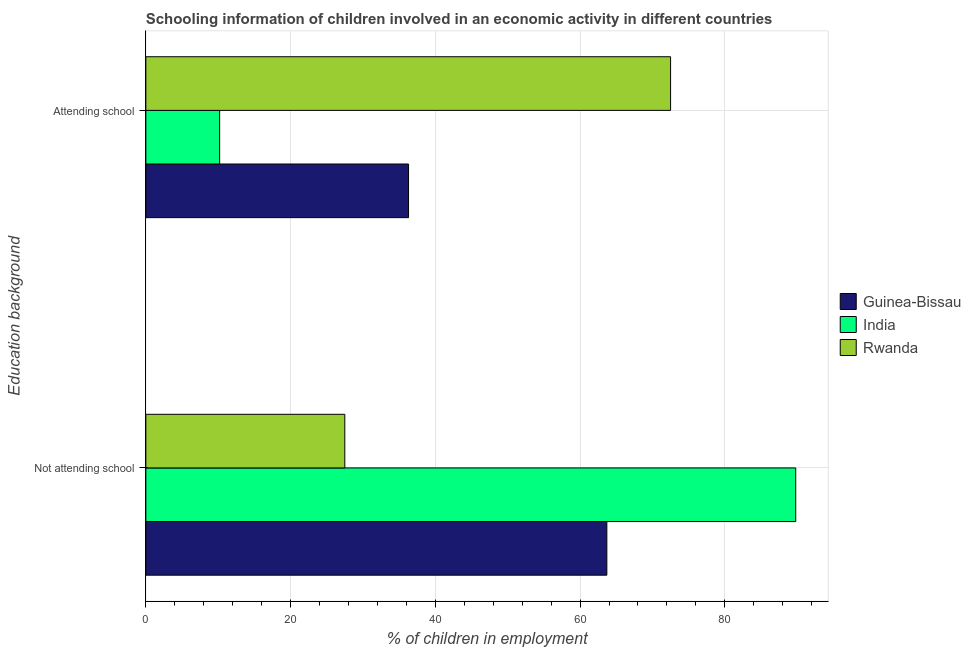Are the number of bars on each tick of the Y-axis equal?
Your answer should be compact. Yes. How many bars are there on the 1st tick from the top?
Provide a succinct answer. 3. What is the label of the 2nd group of bars from the top?
Ensure brevity in your answer.  Not attending school. What is the percentage of employed children who are attending school in Rwanda?
Offer a very short reply. 72.51. Across all countries, what is the maximum percentage of employed children who are not attending school?
Offer a very short reply. 89.8. Across all countries, what is the minimum percentage of employed children who are not attending school?
Your response must be concise. 27.49. In which country was the percentage of employed children who are not attending school minimum?
Keep it short and to the point. Rwanda. What is the total percentage of employed children who are not attending school in the graph?
Ensure brevity in your answer.  180.99. What is the difference between the percentage of employed children who are not attending school in India and that in Guinea-Bissau?
Ensure brevity in your answer.  26.1. What is the difference between the percentage of employed children who are attending school in India and the percentage of employed children who are not attending school in Rwanda?
Provide a short and direct response. -17.29. What is the average percentage of employed children who are not attending school per country?
Provide a short and direct response. 60.33. What is the difference between the percentage of employed children who are not attending school and percentage of employed children who are attending school in Rwanda?
Make the answer very short. -45.02. In how many countries, is the percentage of employed children who are attending school greater than 48 %?
Your answer should be very brief. 1. What is the ratio of the percentage of employed children who are not attending school in Rwanda to that in Guinea-Bissau?
Ensure brevity in your answer.  0.43. In how many countries, is the percentage of employed children who are not attending school greater than the average percentage of employed children who are not attending school taken over all countries?
Provide a succinct answer. 2. What does the 2nd bar from the bottom in Not attending school represents?
Provide a short and direct response. India. Are all the bars in the graph horizontal?
Make the answer very short. Yes. Are the values on the major ticks of X-axis written in scientific E-notation?
Provide a succinct answer. No. Does the graph contain grids?
Your answer should be compact. Yes. How are the legend labels stacked?
Your answer should be very brief. Vertical. What is the title of the graph?
Keep it short and to the point. Schooling information of children involved in an economic activity in different countries. What is the label or title of the X-axis?
Make the answer very short. % of children in employment. What is the label or title of the Y-axis?
Provide a succinct answer. Education background. What is the % of children in employment in Guinea-Bissau in Not attending school?
Provide a short and direct response. 63.7. What is the % of children in employment of India in Not attending school?
Your response must be concise. 89.8. What is the % of children in employment in Rwanda in Not attending school?
Offer a very short reply. 27.49. What is the % of children in employment of Guinea-Bissau in Attending school?
Give a very brief answer. 36.3. What is the % of children in employment in Rwanda in Attending school?
Offer a very short reply. 72.51. Across all Education background, what is the maximum % of children in employment of Guinea-Bissau?
Keep it short and to the point. 63.7. Across all Education background, what is the maximum % of children in employment in India?
Make the answer very short. 89.8. Across all Education background, what is the maximum % of children in employment of Rwanda?
Keep it short and to the point. 72.51. Across all Education background, what is the minimum % of children in employment in Guinea-Bissau?
Ensure brevity in your answer.  36.3. Across all Education background, what is the minimum % of children in employment of Rwanda?
Offer a very short reply. 27.49. What is the total % of children in employment of Guinea-Bissau in the graph?
Your response must be concise. 100. What is the total % of children in employment of India in the graph?
Make the answer very short. 100. What is the total % of children in employment in Rwanda in the graph?
Your answer should be very brief. 100. What is the difference between the % of children in employment in Guinea-Bissau in Not attending school and that in Attending school?
Your response must be concise. 27.4. What is the difference between the % of children in employment in India in Not attending school and that in Attending school?
Offer a very short reply. 79.6. What is the difference between the % of children in employment in Rwanda in Not attending school and that in Attending school?
Make the answer very short. -45.02. What is the difference between the % of children in employment of Guinea-Bissau in Not attending school and the % of children in employment of India in Attending school?
Make the answer very short. 53.5. What is the difference between the % of children in employment in Guinea-Bissau in Not attending school and the % of children in employment in Rwanda in Attending school?
Keep it short and to the point. -8.81. What is the difference between the % of children in employment of India in Not attending school and the % of children in employment of Rwanda in Attending school?
Provide a short and direct response. 17.29. What is the average % of children in employment in Guinea-Bissau per Education background?
Keep it short and to the point. 50. What is the difference between the % of children in employment in Guinea-Bissau and % of children in employment in India in Not attending school?
Your response must be concise. -26.1. What is the difference between the % of children in employment of Guinea-Bissau and % of children in employment of Rwanda in Not attending school?
Provide a short and direct response. 36.21. What is the difference between the % of children in employment in India and % of children in employment in Rwanda in Not attending school?
Ensure brevity in your answer.  62.31. What is the difference between the % of children in employment of Guinea-Bissau and % of children in employment of India in Attending school?
Keep it short and to the point. 26.1. What is the difference between the % of children in employment in Guinea-Bissau and % of children in employment in Rwanda in Attending school?
Ensure brevity in your answer.  -36.21. What is the difference between the % of children in employment of India and % of children in employment of Rwanda in Attending school?
Offer a terse response. -62.31. What is the ratio of the % of children in employment in Guinea-Bissau in Not attending school to that in Attending school?
Your response must be concise. 1.75. What is the ratio of the % of children in employment of India in Not attending school to that in Attending school?
Ensure brevity in your answer.  8.8. What is the ratio of the % of children in employment of Rwanda in Not attending school to that in Attending school?
Ensure brevity in your answer.  0.38. What is the difference between the highest and the second highest % of children in employment of Guinea-Bissau?
Your answer should be very brief. 27.4. What is the difference between the highest and the second highest % of children in employment of India?
Give a very brief answer. 79.6. What is the difference between the highest and the second highest % of children in employment of Rwanda?
Keep it short and to the point. 45.02. What is the difference between the highest and the lowest % of children in employment of Guinea-Bissau?
Give a very brief answer. 27.4. What is the difference between the highest and the lowest % of children in employment of India?
Your response must be concise. 79.6. What is the difference between the highest and the lowest % of children in employment in Rwanda?
Give a very brief answer. 45.02. 